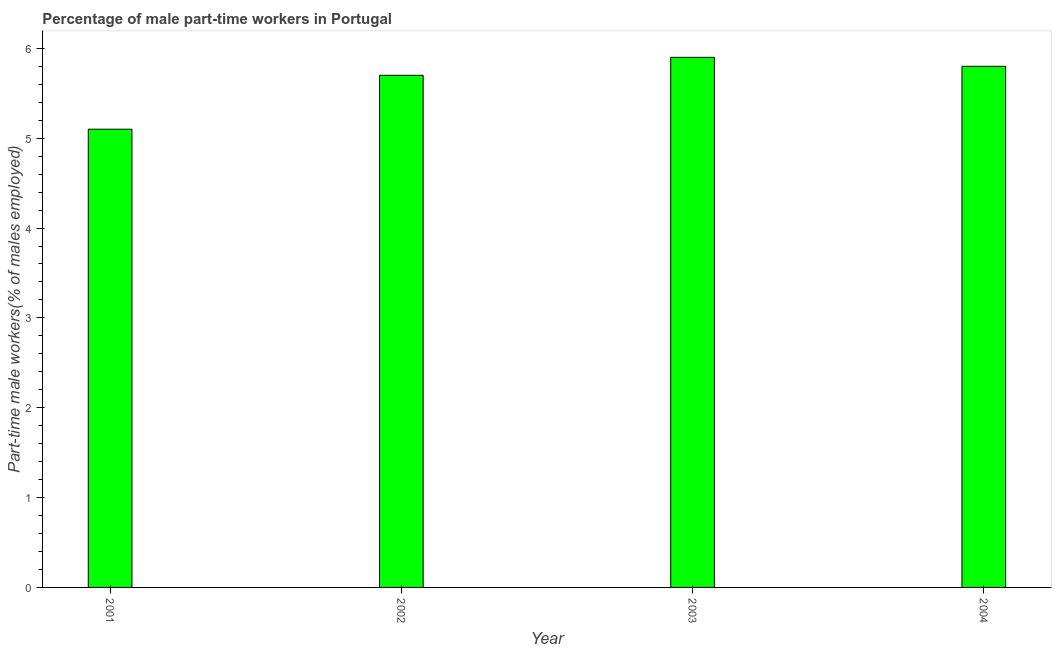Does the graph contain grids?
Provide a succinct answer. No. What is the title of the graph?
Provide a succinct answer. Percentage of male part-time workers in Portugal. What is the label or title of the Y-axis?
Your answer should be very brief. Part-time male workers(% of males employed). What is the percentage of part-time male workers in 2003?
Offer a terse response. 5.9. Across all years, what is the maximum percentage of part-time male workers?
Offer a terse response. 5.9. Across all years, what is the minimum percentage of part-time male workers?
Provide a succinct answer. 5.1. What is the sum of the percentage of part-time male workers?
Keep it short and to the point. 22.5. What is the difference between the percentage of part-time male workers in 2002 and 2004?
Your response must be concise. -0.1. What is the average percentage of part-time male workers per year?
Offer a terse response. 5.62. What is the median percentage of part-time male workers?
Provide a succinct answer. 5.75. In how many years, is the percentage of part-time male workers greater than 3.8 %?
Provide a succinct answer. 4. Do a majority of the years between 2003 and 2004 (inclusive) have percentage of part-time male workers greater than 0.6 %?
Offer a very short reply. Yes. What is the ratio of the percentage of part-time male workers in 2001 to that in 2002?
Give a very brief answer. 0.9. Is the difference between the percentage of part-time male workers in 2001 and 2002 greater than the difference between any two years?
Provide a short and direct response. No. What is the difference between the highest and the second highest percentage of part-time male workers?
Ensure brevity in your answer.  0.1. Is the sum of the percentage of part-time male workers in 2002 and 2003 greater than the maximum percentage of part-time male workers across all years?
Provide a short and direct response. Yes. What is the difference between the highest and the lowest percentage of part-time male workers?
Your answer should be very brief. 0.8. Are all the bars in the graph horizontal?
Keep it short and to the point. No. How many years are there in the graph?
Make the answer very short. 4. What is the difference between two consecutive major ticks on the Y-axis?
Provide a short and direct response. 1. What is the Part-time male workers(% of males employed) in 2001?
Give a very brief answer. 5.1. What is the Part-time male workers(% of males employed) in 2002?
Provide a short and direct response. 5.7. What is the Part-time male workers(% of males employed) of 2003?
Keep it short and to the point. 5.9. What is the Part-time male workers(% of males employed) of 2004?
Offer a terse response. 5.8. What is the difference between the Part-time male workers(% of males employed) in 2001 and 2002?
Offer a very short reply. -0.6. What is the difference between the Part-time male workers(% of males employed) in 2001 and 2003?
Offer a very short reply. -0.8. What is the difference between the Part-time male workers(% of males employed) in 2001 and 2004?
Provide a short and direct response. -0.7. What is the ratio of the Part-time male workers(% of males employed) in 2001 to that in 2002?
Ensure brevity in your answer.  0.9. What is the ratio of the Part-time male workers(% of males employed) in 2001 to that in 2003?
Provide a short and direct response. 0.86. What is the ratio of the Part-time male workers(% of males employed) in 2001 to that in 2004?
Ensure brevity in your answer.  0.88. What is the ratio of the Part-time male workers(% of males employed) in 2002 to that in 2003?
Offer a terse response. 0.97. What is the ratio of the Part-time male workers(% of males employed) in 2002 to that in 2004?
Provide a succinct answer. 0.98. What is the ratio of the Part-time male workers(% of males employed) in 2003 to that in 2004?
Provide a short and direct response. 1.02. 